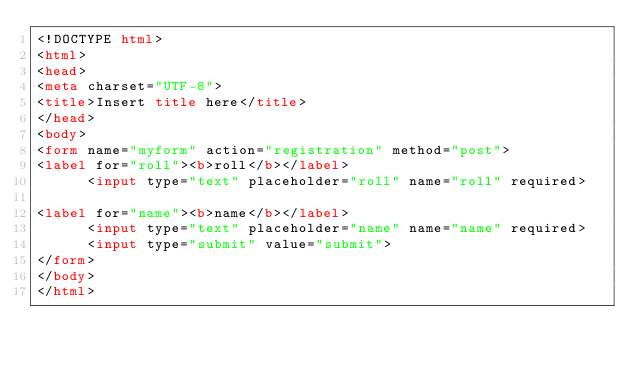Convert code to text. <code><loc_0><loc_0><loc_500><loc_500><_HTML_><!DOCTYPE html>
<html>
<head>
<meta charset="UTF-8">
<title>Insert title here</title>
</head>
<body>
<form name="myform" action="registration" method="post">
<label for="roll"><b>roll</b></label>
      <input type="text" placeholder="roll" name="roll" required>

<label for="name"><b>name</b></label>
      <input type="text" placeholder="name" name="name" required>
      <input type="submit" value="submit">
</form>
</body>
</html></code> 